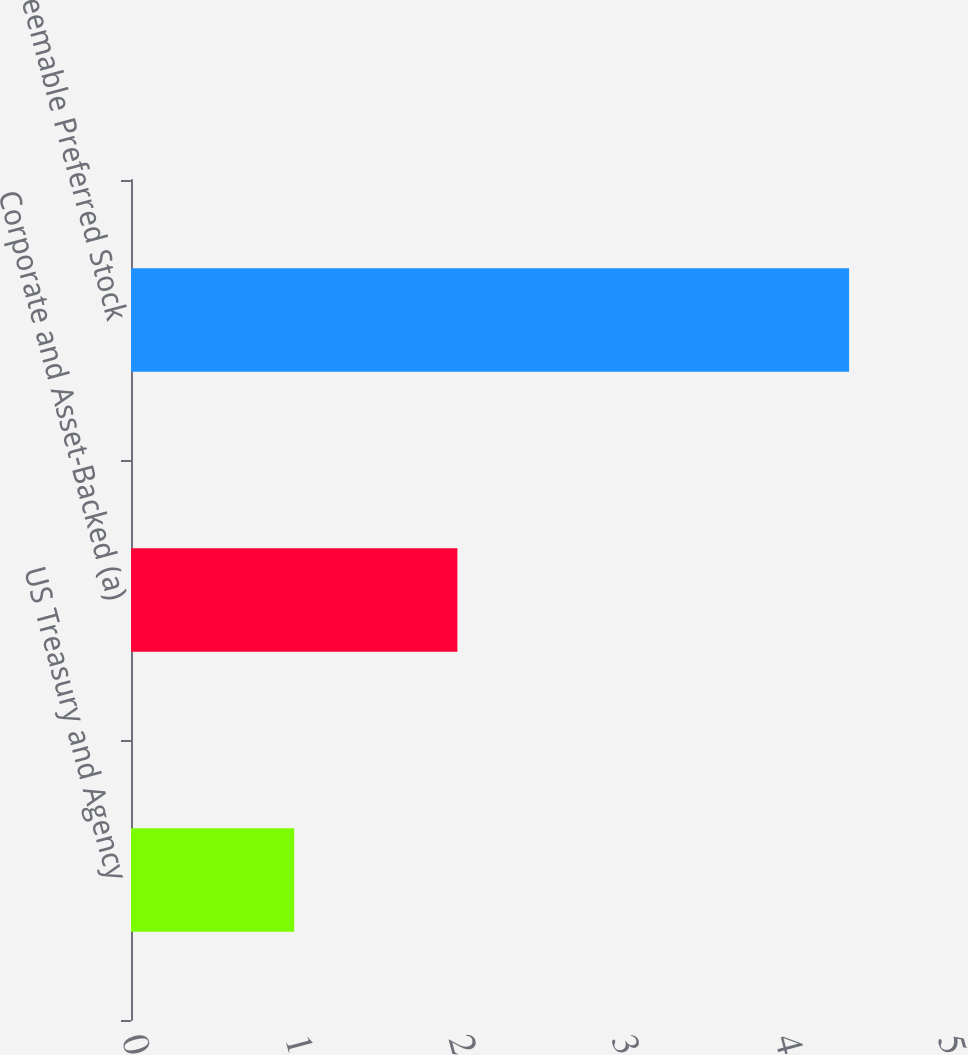<chart> <loc_0><loc_0><loc_500><loc_500><bar_chart><fcel>US Treasury and Agency<fcel>Corporate and Asset-Backed (a)<fcel>Redeemable Preferred Stock<nl><fcel>1<fcel>2<fcel>4.4<nl></chart> 